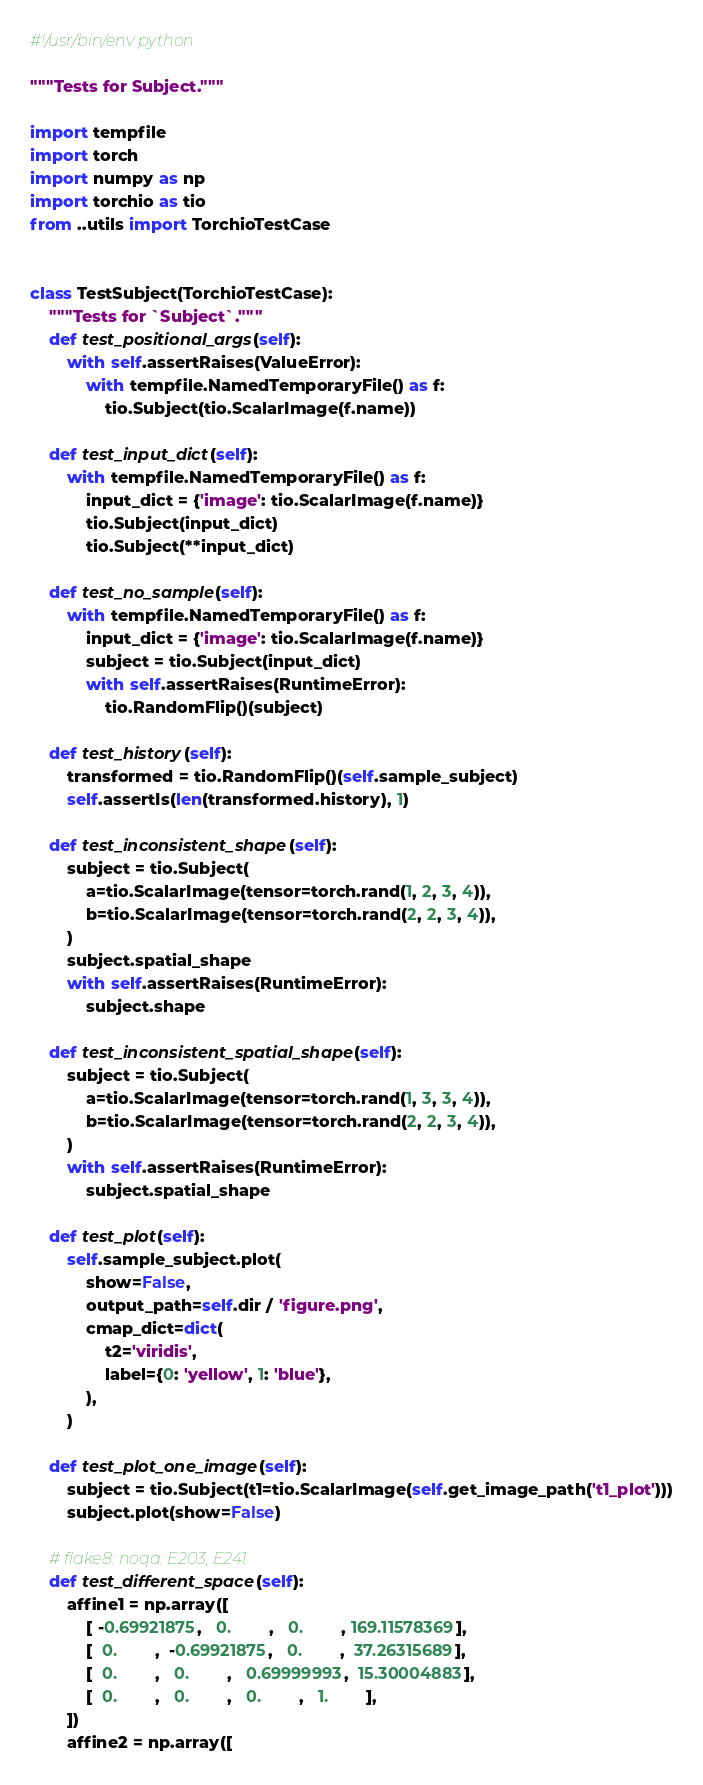Convert code to text. <code><loc_0><loc_0><loc_500><loc_500><_Python_>#!/usr/bin/env python

"""Tests for Subject."""

import tempfile
import torch
import numpy as np
import torchio as tio
from ..utils import TorchioTestCase


class TestSubject(TorchioTestCase):
    """Tests for `Subject`."""
    def test_positional_args(self):
        with self.assertRaises(ValueError):
            with tempfile.NamedTemporaryFile() as f:
                tio.Subject(tio.ScalarImage(f.name))

    def test_input_dict(self):
        with tempfile.NamedTemporaryFile() as f:
            input_dict = {'image': tio.ScalarImage(f.name)}
            tio.Subject(input_dict)
            tio.Subject(**input_dict)

    def test_no_sample(self):
        with tempfile.NamedTemporaryFile() as f:
            input_dict = {'image': tio.ScalarImage(f.name)}
            subject = tio.Subject(input_dict)
            with self.assertRaises(RuntimeError):
                tio.RandomFlip()(subject)

    def test_history(self):
        transformed = tio.RandomFlip()(self.sample_subject)
        self.assertIs(len(transformed.history), 1)

    def test_inconsistent_shape(self):
        subject = tio.Subject(
            a=tio.ScalarImage(tensor=torch.rand(1, 2, 3, 4)),
            b=tio.ScalarImage(tensor=torch.rand(2, 2, 3, 4)),
        )
        subject.spatial_shape
        with self.assertRaises(RuntimeError):
            subject.shape

    def test_inconsistent_spatial_shape(self):
        subject = tio.Subject(
            a=tio.ScalarImage(tensor=torch.rand(1, 3, 3, 4)),
            b=tio.ScalarImage(tensor=torch.rand(2, 2, 3, 4)),
        )
        with self.assertRaises(RuntimeError):
            subject.spatial_shape

    def test_plot(self):
        self.sample_subject.plot(
            show=False,
            output_path=self.dir / 'figure.png',
            cmap_dict=dict(
                t2='viridis',
                label={0: 'yellow', 1: 'blue'},
            ),
        )

    def test_plot_one_image(self):
        subject = tio.Subject(t1=tio.ScalarImage(self.get_image_path('t1_plot')))
        subject.plot(show=False)

    # flake8: noqa: E203, E241
    def test_different_space(self):
        affine1 = np.array([
            [ -0.69921875,   0.        ,   0.        , 169.11578369],
            [  0.        ,  -0.69921875,   0.        ,  37.26315689],
            [  0.        ,   0.        ,   0.69999993,  15.30004883],
            [  0.        ,   0.        ,   0.        ,   1.        ],
        ])
        affine2 = np.array([</code> 